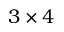Convert formula to latex. <formula><loc_0><loc_0><loc_500><loc_500>3 \times 4</formula> 